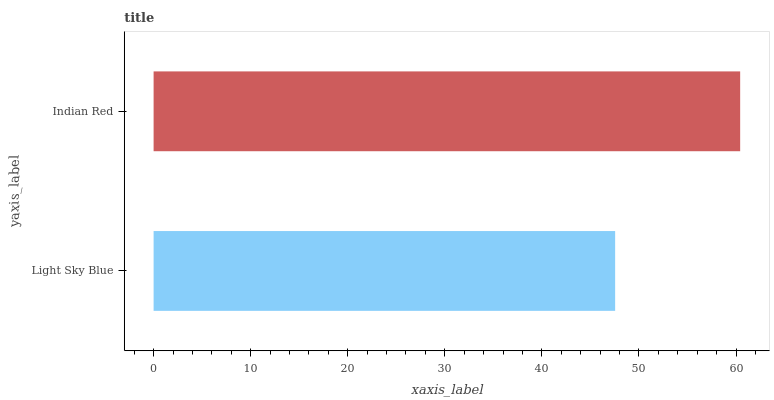Is Light Sky Blue the minimum?
Answer yes or no. Yes. Is Indian Red the maximum?
Answer yes or no. Yes. Is Indian Red the minimum?
Answer yes or no. No. Is Indian Red greater than Light Sky Blue?
Answer yes or no. Yes. Is Light Sky Blue less than Indian Red?
Answer yes or no. Yes. Is Light Sky Blue greater than Indian Red?
Answer yes or no. No. Is Indian Red less than Light Sky Blue?
Answer yes or no. No. Is Indian Red the high median?
Answer yes or no. Yes. Is Light Sky Blue the low median?
Answer yes or no. Yes. Is Light Sky Blue the high median?
Answer yes or no. No. Is Indian Red the low median?
Answer yes or no. No. 